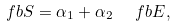Convert formula to latex. <formula><loc_0><loc_0><loc_500><loc_500>\ f b { S } = \alpha _ { 1 } + \alpha _ { 2 } \ \ f b { E } ,</formula> 